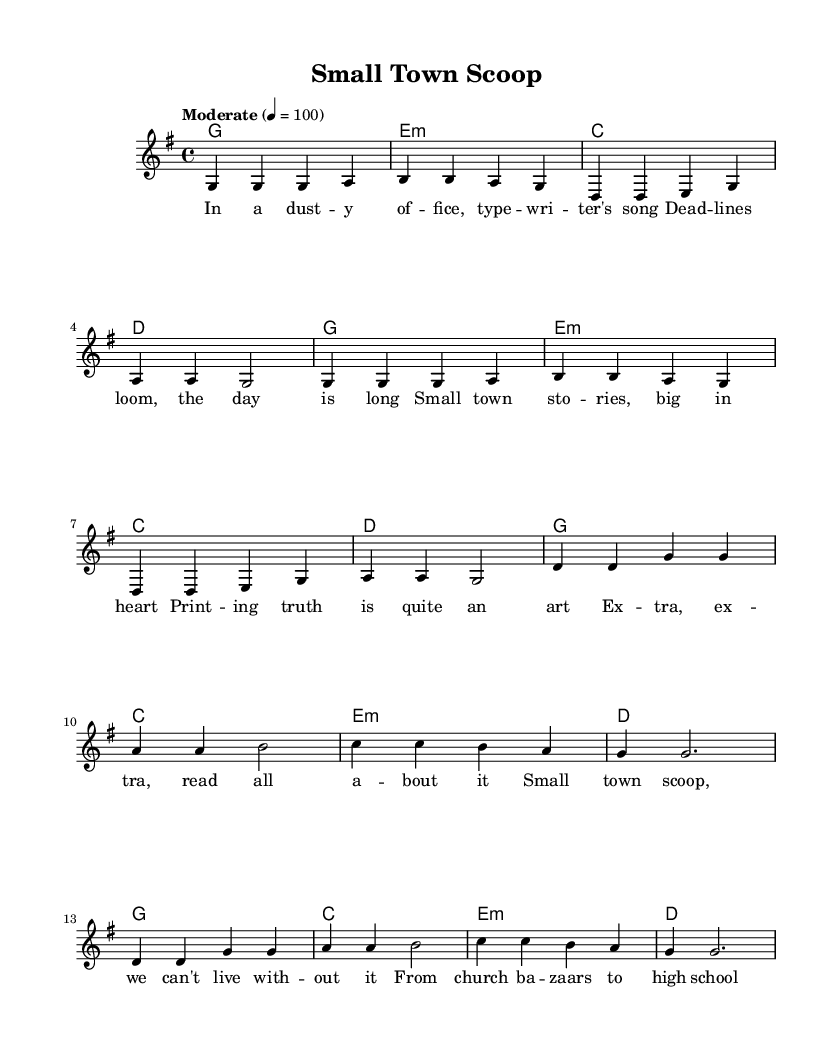What is the key signature of this music? The key signature is G major, which has one sharp (F#). This can be identified at the beginning of the staff where the key signature is indicated.
Answer: G major What is the time signature of the piece? The time signature is 4/4, as shown at the beginning of the music sheet. This indicates that there are four beats in each measure and a quarter note receives one beat.
Answer: 4/4 What is the tempo marking for this piece? The tempo marking is "Moderate" at a rate of 100 beats per minute, noted in the tempo indication above the staff.
Answer: Moderate 4 = 100 How many lines of lyrics are in the verse? The verse contains four lines of lyrics, which can be counted by looking at the verseWords section.
Answer: 4 What is the structure of the song (verse and chorus)? The song consists of two sections: a verse followed by a chorus. The verse is repeated before the chorus, and this makes up the overall structure of the song.
Answer: Verse, Chorus What is the last note of the chorus? The last note of the chorus is a half note (g) that ties into the conclusion of this section. This is determined by scanning the notes of the chorus.
Answer: g What do the lyrics of the song primarily discuss? The lyrics discuss life in a small-town newspaper, focusing on stories and events relevant to the community, as suggested by the content of both the verse and chorus lyrics.
Answer: Small-town newspaper life 